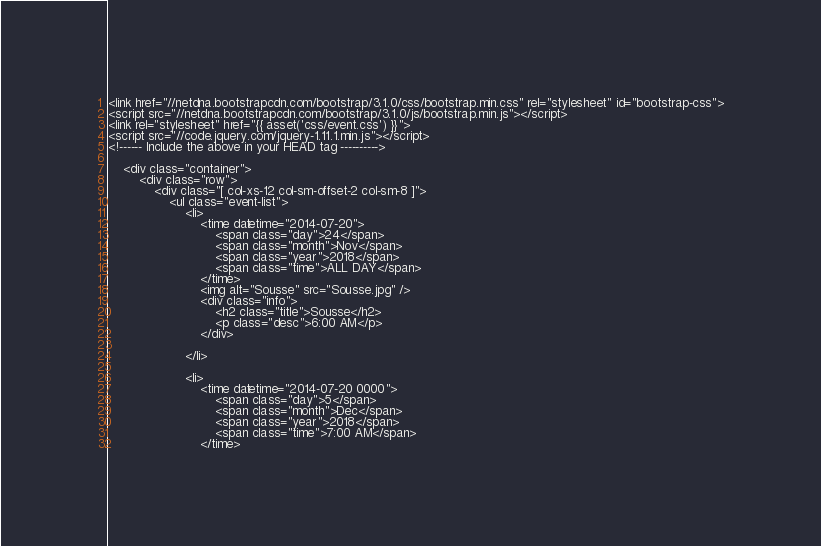Convert code to text. <code><loc_0><loc_0><loc_500><loc_500><_PHP_><link href="//netdna.bootstrapcdn.com/bootstrap/3.1.0/css/bootstrap.min.css" rel="stylesheet" id="bootstrap-css">
<script src="//netdna.bootstrapcdn.com/bootstrap/3.1.0/js/bootstrap.min.js"></script>
<link rel="stylesheet" href="{{ asset('css/event.css') }}">
<script src="//code.jquery.com/jquery-1.11.1.min.js"></script>
<!------ Include the above in your HEAD tag ---------->

    <div class="container">
        <div class="row">
            <div class="[ col-xs-12 col-sm-offset-2 col-sm-8 ]">
                <ul class="event-list">
                    <li>
                        <time datetime="2014-07-20">
                            <span class="day">24</span>
                            <span class="month">Nov</span>
                            <span class="year">2018</span>
                            <span class="time">ALL DAY</span>
                        </time>
                        <img alt="Sousse" src="Sousse.jpg" />
                        <div class="info">
                            <h2 class="title">Sousse</h2>
                            <p class="desc">6:00 AM</p>
                        </div>
                       
                    </li>

                    <li>
                        <time datetime="2014-07-20 0000">
                            <span class="day">5</span>
                            <span class="month">Dec</span>
                            <span class="year">2018</span>
                            <span class="time">7:00 AM</span>
                        </time></code> 